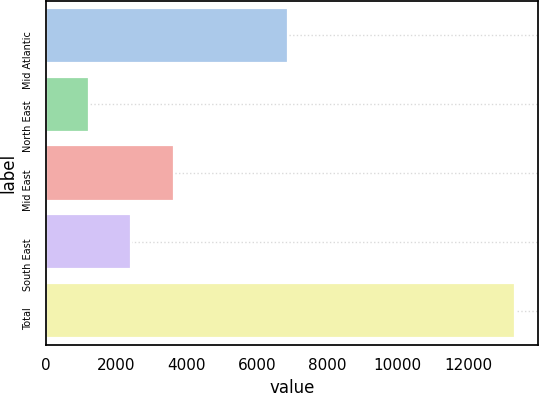Convert chart. <chart><loc_0><loc_0><loc_500><loc_500><bar_chart><fcel>Mid Atlantic<fcel>North East<fcel>Mid East<fcel>South East<fcel>Total<nl><fcel>6879<fcel>1221<fcel>3642<fcel>2431.5<fcel>13326<nl></chart> 